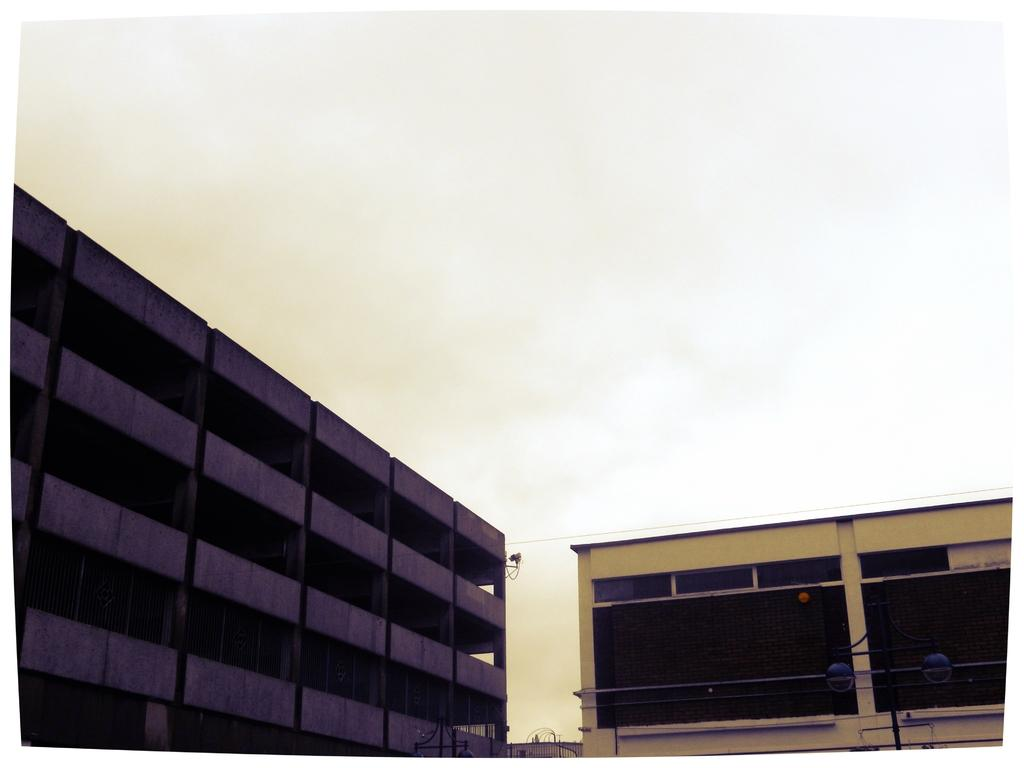What structures are located in the foreground of the image? There are buildings and gates in the foreground of the image. What else can be seen at the bottom side of the image? There is a lamp pole at the bottom side of the image. What is visible in the background of the image? The sky is visible in the background of the image. Can you tell me how many sugar cubes are on the lamp pole in the image? There are no sugar cubes present on the lamp pole in the image. Is anyone driving a vehicle in the image? There is no vehicle or person driving visible in the image. 